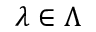<formula> <loc_0><loc_0><loc_500><loc_500>\lambda \in \Lambda</formula> 